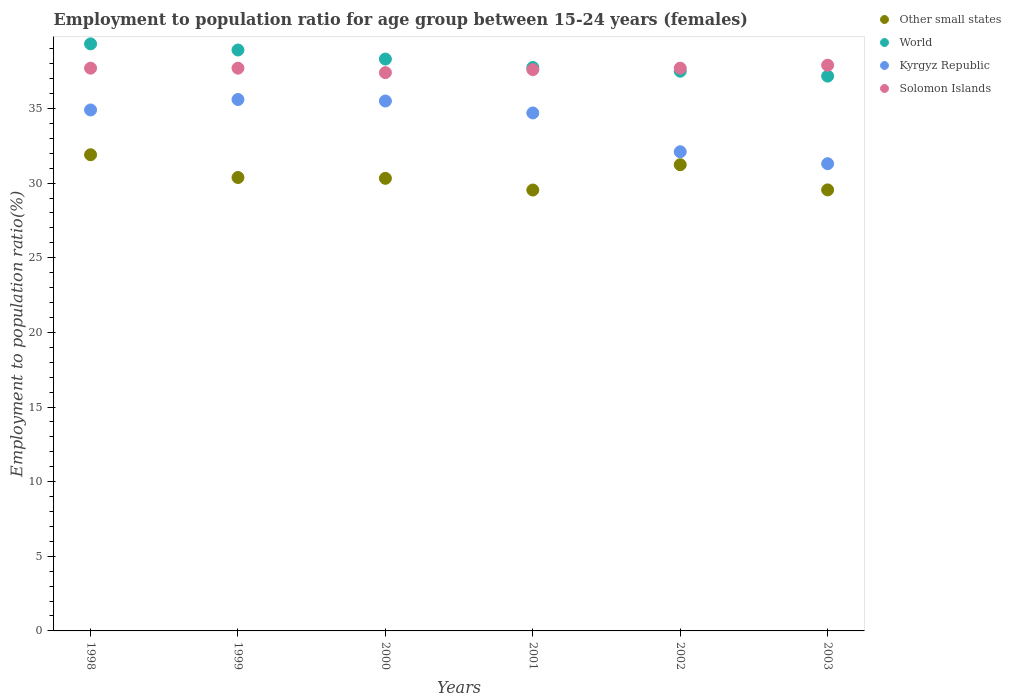How many different coloured dotlines are there?
Your answer should be compact. 4. What is the employment to population ratio in Other small states in 2003?
Keep it short and to the point. 29.55. Across all years, what is the maximum employment to population ratio in World?
Provide a succinct answer. 39.33. Across all years, what is the minimum employment to population ratio in Kyrgyz Republic?
Offer a terse response. 31.3. In which year was the employment to population ratio in Solomon Islands maximum?
Give a very brief answer. 2003. In which year was the employment to population ratio in Solomon Islands minimum?
Ensure brevity in your answer.  2000. What is the total employment to population ratio in World in the graph?
Your answer should be very brief. 228.97. What is the difference between the employment to population ratio in Kyrgyz Republic in 1999 and that in 2001?
Provide a succinct answer. 0.9. What is the difference between the employment to population ratio in Other small states in 2003 and the employment to population ratio in Kyrgyz Republic in 1999?
Offer a very short reply. -6.05. What is the average employment to population ratio in Kyrgyz Republic per year?
Your response must be concise. 34.02. In the year 1999, what is the difference between the employment to population ratio in World and employment to population ratio in Solomon Islands?
Offer a very short reply. 1.22. What is the ratio of the employment to population ratio in Other small states in 1999 to that in 2000?
Your response must be concise. 1. What is the difference between the highest and the second highest employment to population ratio in Other small states?
Keep it short and to the point. 0.67. Is it the case that in every year, the sum of the employment to population ratio in World and employment to population ratio in Solomon Islands  is greater than the sum of employment to population ratio in Other small states and employment to population ratio in Kyrgyz Republic?
Ensure brevity in your answer.  No. Is it the case that in every year, the sum of the employment to population ratio in Kyrgyz Republic and employment to population ratio in Other small states  is greater than the employment to population ratio in Solomon Islands?
Ensure brevity in your answer.  Yes. Does the employment to population ratio in Other small states monotonically increase over the years?
Your answer should be very brief. No. Is the employment to population ratio in Kyrgyz Republic strictly greater than the employment to population ratio in Solomon Islands over the years?
Offer a terse response. No. How many years are there in the graph?
Ensure brevity in your answer.  6. What is the difference between two consecutive major ticks on the Y-axis?
Your answer should be very brief. 5. Are the values on the major ticks of Y-axis written in scientific E-notation?
Provide a short and direct response. No. Does the graph contain grids?
Your answer should be very brief. No. How are the legend labels stacked?
Provide a short and direct response. Vertical. What is the title of the graph?
Keep it short and to the point. Employment to population ratio for age group between 15-24 years (females). What is the label or title of the Y-axis?
Keep it short and to the point. Employment to population ratio(%). What is the Employment to population ratio(%) of Other small states in 1998?
Provide a succinct answer. 31.9. What is the Employment to population ratio(%) in World in 1998?
Ensure brevity in your answer.  39.33. What is the Employment to population ratio(%) of Kyrgyz Republic in 1998?
Make the answer very short. 34.9. What is the Employment to population ratio(%) in Solomon Islands in 1998?
Ensure brevity in your answer.  37.7. What is the Employment to population ratio(%) of Other small states in 1999?
Ensure brevity in your answer.  30.38. What is the Employment to population ratio(%) of World in 1999?
Ensure brevity in your answer.  38.92. What is the Employment to population ratio(%) of Kyrgyz Republic in 1999?
Offer a terse response. 35.6. What is the Employment to population ratio(%) in Solomon Islands in 1999?
Offer a very short reply. 37.7. What is the Employment to population ratio(%) of Other small states in 2000?
Provide a short and direct response. 30.32. What is the Employment to population ratio(%) in World in 2000?
Ensure brevity in your answer.  38.31. What is the Employment to population ratio(%) of Kyrgyz Republic in 2000?
Ensure brevity in your answer.  35.5. What is the Employment to population ratio(%) of Solomon Islands in 2000?
Offer a terse response. 37.4. What is the Employment to population ratio(%) in Other small states in 2001?
Your answer should be very brief. 29.54. What is the Employment to population ratio(%) of World in 2001?
Make the answer very short. 37.75. What is the Employment to population ratio(%) of Kyrgyz Republic in 2001?
Make the answer very short. 34.7. What is the Employment to population ratio(%) of Solomon Islands in 2001?
Make the answer very short. 37.6. What is the Employment to population ratio(%) in Other small states in 2002?
Give a very brief answer. 31.23. What is the Employment to population ratio(%) in World in 2002?
Provide a short and direct response. 37.5. What is the Employment to population ratio(%) in Kyrgyz Republic in 2002?
Keep it short and to the point. 32.1. What is the Employment to population ratio(%) in Solomon Islands in 2002?
Make the answer very short. 37.7. What is the Employment to population ratio(%) of Other small states in 2003?
Provide a succinct answer. 29.55. What is the Employment to population ratio(%) in World in 2003?
Ensure brevity in your answer.  37.17. What is the Employment to population ratio(%) of Kyrgyz Republic in 2003?
Provide a short and direct response. 31.3. What is the Employment to population ratio(%) in Solomon Islands in 2003?
Provide a short and direct response. 37.9. Across all years, what is the maximum Employment to population ratio(%) of Other small states?
Your answer should be very brief. 31.9. Across all years, what is the maximum Employment to population ratio(%) of World?
Provide a succinct answer. 39.33. Across all years, what is the maximum Employment to population ratio(%) of Kyrgyz Republic?
Provide a short and direct response. 35.6. Across all years, what is the maximum Employment to population ratio(%) of Solomon Islands?
Ensure brevity in your answer.  37.9. Across all years, what is the minimum Employment to population ratio(%) in Other small states?
Give a very brief answer. 29.54. Across all years, what is the minimum Employment to population ratio(%) of World?
Provide a succinct answer. 37.17. Across all years, what is the minimum Employment to population ratio(%) of Kyrgyz Republic?
Keep it short and to the point. 31.3. Across all years, what is the minimum Employment to population ratio(%) in Solomon Islands?
Your response must be concise. 37.4. What is the total Employment to population ratio(%) in Other small states in the graph?
Your answer should be very brief. 182.91. What is the total Employment to population ratio(%) in World in the graph?
Offer a terse response. 228.97. What is the total Employment to population ratio(%) in Kyrgyz Republic in the graph?
Your response must be concise. 204.1. What is the total Employment to population ratio(%) in Solomon Islands in the graph?
Provide a succinct answer. 226. What is the difference between the Employment to population ratio(%) in Other small states in 1998 and that in 1999?
Provide a succinct answer. 1.52. What is the difference between the Employment to population ratio(%) of World in 1998 and that in 1999?
Provide a short and direct response. 0.41. What is the difference between the Employment to population ratio(%) in Kyrgyz Republic in 1998 and that in 1999?
Give a very brief answer. -0.7. What is the difference between the Employment to population ratio(%) in Solomon Islands in 1998 and that in 1999?
Provide a short and direct response. 0. What is the difference between the Employment to population ratio(%) of Other small states in 1998 and that in 2000?
Ensure brevity in your answer.  1.58. What is the difference between the Employment to population ratio(%) of World in 1998 and that in 2000?
Give a very brief answer. 1.02. What is the difference between the Employment to population ratio(%) of Other small states in 1998 and that in 2001?
Your answer should be very brief. 2.36. What is the difference between the Employment to population ratio(%) of World in 1998 and that in 2001?
Offer a terse response. 1.58. What is the difference between the Employment to population ratio(%) in Kyrgyz Republic in 1998 and that in 2001?
Offer a very short reply. 0.2. What is the difference between the Employment to population ratio(%) in Solomon Islands in 1998 and that in 2001?
Offer a terse response. 0.1. What is the difference between the Employment to population ratio(%) in Other small states in 1998 and that in 2002?
Provide a succinct answer. 0.67. What is the difference between the Employment to population ratio(%) in World in 1998 and that in 2002?
Offer a very short reply. 1.83. What is the difference between the Employment to population ratio(%) of Other small states in 1998 and that in 2003?
Offer a very short reply. 2.35. What is the difference between the Employment to population ratio(%) of World in 1998 and that in 2003?
Offer a very short reply. 2.16. What is the difference between the Employment to population ratio(%) of Kyrgyz Republic in 1998 and that in 2003?
Offer a very short reply. 3.6. What is the difference between the Employment to population ratio(%) in Other small states in 1999 and that in 2000?
Your answer should be very brief. 0.06. What is the difference between the Employment to population ratio(%) of World in 1999 and that in 2000?
Provide a succinct answer. 0.61. What is the difference between the Employment to population ratio(%) in Solomon Islands in 1999 and that in 2000?
Make the answer very short. 0.3. What is the difference between the Employment to population ratio(%) in Other small states in 1999 and that in 2001?
Your response must be concise. 0.84. What is the difference between the Employment to population ratio(%) of World in 1999 and that in 2001?
Keep it short and to the point. 1.17. What is the difference between the Employment to population ratio(%) of Solomon Islands in 1999 and that in 2001?
Provide a succinct answer. 0.1. What is the difference between the Employment to population ratio(%) of Other small states in 1999 and that in 2002?
Your response must be concise. -0.86. What is the difference between the Employment to population ratio(%) of World in 1999 and that in 2002?
Give a very brief answer. 1.42. What is the difference between the Employment to population ratio(%) of Other small states in 1999 and that in 2003?
Make the answer very short. 0.83. What is the difference between the Employment to population ratio(%) in World in 1999 and that in 2003?
Give a very brief answer. 1.75. What is the difference between the Employment to population ratio(%) in Solomon Islands in 1999 and that in 2003?
Offer a very short reply. -0.2. What is the difference between the Employment to population ratio(%) in Other small states in 2000 and that in 2001?
Give a very brief answer. 0.78. What is the difference between the Employment to population ratio(%) of World in 2000 and that in 2001?
Make the answer very short. 0.57. What is the difference between the Employment to population ratio(%) in Solomon Islands in 2000 and that in 2001?
Provide a short and direct response. -0.2. What is the difference between the Employment to population ratio(%) of Other small states in 2000 and that in 2002?
Give a very brief answer. -0.91. What is the difference between the Employment to population ratio(%) of World in 2000 and that in 2002?
Ensure brevity in your answer.  0.81. What is the difference between the Employment to population ratio(%) in Kyrgyz Republic in 2000 and that in 2002?
Provide a short and direct response. 3.4. What is the difference between the Employment to population ratio(%) of Solomon Islands in 2000 and that in 2002?
Offer a terse response. -0.3. What is the difference between the Employment to population ratio(%) in Other small states in 2000 and that in 2003?
Ensure brevity in your answer.  0.78. What is the difference between the Employment to population ratio(%) of World in 2000 and that in 2003?
Keep it short and to the point. 1.14. What is the difference between the Employment to population ratio(%) in Kyrgyz Republic in 2000 and that in 2003?
Make the answer very short. 4.2. What is the difference between the Employment to population ratio(%) of Solomon Islands in 2000 and that in 2003?
Your answer should be compact. -0.5. What is the difference between the Employment to population ratio(%) of Other small states in 2001 and that in 2002?
Your answer should be very brief. -1.69. What is the difference between the Employment to population ratio(%) of World in 2001 and that in 2002?
Your answer should be compact. 0.25. What is the difference between the Employment to population ratio(%) of Kyrgyz Republic in 2001 and that in 2002?
Your response must be concise. 2.6. What is the difference between the Employment to population ratio(%) of Other small states in 2001 and that in 2003?
Your answer should be very brief. -0.01. What is the difference between the Employment to population ratio(%) in World in 2001 and that in 2003?
Give a very brief answer. 0.58. What is the difference between the Employment to population ratio(%) of Other small states in 2002 and that in 2003?
Give a very brief answer. 1.69. What is the difference between the Employment to population ratio(%) in World in 2002 and that in 2003?
Provide a succinct answer. 0.33. What is the difference between the Employment to population ratio(%) of Other small states in 1998 and the Employment to population ratio(%) of World in 1999?
Offer a terse response. -7.02. What is the difference between the Employment to population ratio(%) in Other small states in 1998 and the Employment to population ratio(%) in Kyrgyz Republic in 1999?
Your response must be concise. -3.7. What is the difference between the Employment to population ratio(%) in Other small states in 1998 and the Employment to population ratio(%) in Solomon Islands in 1999?
Your answer should be compact. -5.8. What is the difference between the Employment to population ratio(%) of World in 1998 and the Employment to population ratio(%) of Kyrgyz Republic in 1999?
Offer a very short reply. 3.73. What is the difference between the Employment to population ratio(%) of World in 1998 and the Employment to population ratio(%) of Solomon Islands in 1999?
Provide a short and direct response. 1.63. What is the difference between the Employment to population ratio(%) of Other small states in 1998 and the Employment to population ratio(%) of World in 2000?
Give a very brief answer. -6.41. What is the difference between the Employment to population ratio(%) in Other small states in 1998 and the Employment to population ratio(%) in Kyrgyz Republic in 2000?
Provide a short and direct response. -3.6. What is the difference between the Employment to population ratio(%) in Other small states in 1998 and the Employment to population ratio(%) in Solomon Islands in 2000?
Provide a short and direct response. -5.5. What is the difference between the Employment to population ratio(%) in World in 1998 and the Employment to population ratio(%) in Kyrgyz Republic in 2000?
Offer a terse response. 3.83. What is the difference between the Employment to population ratio(%) of World in 1998 and the Employment to population ratio(%) of Solomon Islands in 2000?
Offer a very short reply. 1.93. What is the difference between the Employment to population ratio(%) in Other small states in 1998 and the Employment to population ratio(%) in World in 2001?
Provide a succinct answer. -5.85. What is the difference between the Employment to population ratio(%) of Other small states in 1998 and the Employment to population ratio(%) of Kyrgyz Republic in 2001?
Ensure brevity in your answer.  -2.8. What is the difference between the Employment to population ratio(%) in Other small states in 1998 and the Employment to population ratio(%) in Solomon Islands in 2001?
Give a very brief answer. -5.7. What is the difference between the Employment to population ratio(%) in World in 1998 and the Employment to population ratio(%) in Kyrgyz Republic in 2001?
Offer a terse response. 4.63. What is the difference between the Employment to population ratio(%) of World in 1998 and the Employment to population ratio(%) of Solomon Islands in 2001?
Ensure brevity in your answer.  1.73. What is the difference between the Employment to population ratio(%) in Kyrgyz Republic in 1998 and the Employment to population ratio(%) in Solomon Islands in 2001?
Ensure brevity in your answer.  -2.7. What is the difference between the Employment to population ratio(%) of Other small states in 1998 and the Employment to population ratio(%) of World in 2002?
Your answer should be very brief. -5.6. What is the difference between the Employment to population ratio(%) in Other small states in 1998 and the Employment to population ratio(%) in Kyrgyz Republic in 2002?
Your answer should be very brief. -0.2. What is the difference between the Employment to population ratio(%) of Other small states in 1998 and the Employment to population ratio(%) of Solomon Islands in 2002?
Provide a short and direct response. -5.8. What is the difference between the Employment to population ratio(%) in World in 1998 and the Employment to population ratio(%) in Kyrgyz Republic in 2002?
Your response must be concise. 7.23. What is the difference between the Employment to population ratio(%) in World in 1998 and the Employment to population ratio(%) in Solomon Islands in 2002?
Your answer should be very brief. 1.63. What is the difference between the Employment to population ratio(%) in Other small states in 1998 and the Employment to population ratio(%) in World in 2003?
Provide a succinct answer. -5.27. What is the difference between the Employment to population ratio(%) of Other small states in 1998 and the Employment to population ratio(%) of Kyrgyz Republic in 2003?
Offer a terse response. 0.6. What is the difference between the Employment to population ratio(%) of Other small states in 1998 and the Employment to population ratio(%) of Solomon Islands in 2003?
Offer a terse response. -6. What is the difference between the Employment to population ratio(%) in World in 1998 and the Employment to population ratio(%) in Kyrgyz Republic in 2003?
Offer a very short reply. 8.03. What is the difference between the Employment to population ratio(%) of World in 1998 and the Employment to population ratio(%) of Solomon Islands in 2003?
Offer a terse response. 1.43. What is the difference between the Employment to population ratio(%) of Other small states in 1999 and the Employment to population ratio(%) of World in 2000?
Make the answer very short. -7.93. What is the difference between the Employment to population ratio(%) of Other small states in 1999 and the Employment to population ratio(%) of Kyrgyz Republic in 2000?
Offer a very short reply. -5.12. What is the difference between the Employment to population ratio(%) of Other small states in 1999 and the Employment to population ratio(%) of Solomon Islands in 2000?
Ensure brevity in your answer.  -7.02. What is the difference between the Employment to population ratio(%) in World in 1999 and the Employment to population ratio(%) in Kyrgyz Republic in 2000?
Give a very brief answer. 3.42. What is the difference between the Employment to population ratio(%) of World in 1999 and the Employment to population ratio(%) of Solomon Islands in 2000?
Offer a terse response. 1.52. What is the difference between the Employment to population ratio(%) of Kyrgyz Republic in 1999 and the Employment to population ratio(%) of Solomon Islands in 2000?
Ensure brevity in your answer.  -1.8. What is the difference between the Employment to population ratio(%) of Other small states in 1999 and the Employment to population ratio(%) of World in 2001?
Keep it short and to the point. -7.37. What is the difference between the Employment to population ratio(%) of Other small states in 1999 and the Employment to population ratio(%) of Kyrgyz Republic in 2001?
Your answer should be compact. -4.32. What is the difference between the Employment to population ratio(%) in Other small states in 1999 and the Employment to population ratio(%) in Solomon Islands in 2001?
Offer a very short reply. -7.22. What is the difference between the Employment to population ratio(%) of World in 1999 and the Employment to population ratio(%) of Kyrgyz Republic in 2001?
Ensure brevity in your answer.  4.22. What is the difference between the Employment to population ratio(%) of World in 1999 and the Employment to population ratio(%) of Solomon Islands in 2001?
Your answer should be very brief. 1.32. What is the difference between the Employment to population ratio(%) of Kyrgyz Republic in 1999 and the Employment to population ratio(%) of Solomon Islands in 2001?
Ensure brevity in your answer.  -2. What is the difference between the Employment to population ratio(%) of Other small states in 1999 and the Employment to population ratio(%) of World in 2002?
Make the answer very short. -7.12. What is the difference between the Employment to population ratio(%) in Other small states in 1999 and the Employment to population ratio(%) in Kyrgyz Republic in 2002?
Make the answer very short. -1.72. What is the difference between the Employment to population ratio(%) of Other small states in 1999 and the Employment to population ratio(%) of Solomon Islands in 2002?
Make the answer very short. -7.32. What is the difference between the Employment to population ratio(%) of World in 1999 and the Employment to population ratio(%) of Kyrgyz Republic in 2002?
Ensure brevity in your answer.  6.82. What is the difference between the Employment to population ratio(%) of World in 1999 and the Employment to population ratio(%) of Solomon Islands in 2002?
Offer a terse response. 1.22. What is the difference between the Employment to population ratio(%) in Kyrgyz Republic in 1999 and the Employment to population ratio(%) in Solomon Islands in 2002?
Offer a terse response. -2.1. What is the difference between the Employment to population ratio(%) in Other small states in 1999 and the Employment to population ratio(%) in World in 2003?
Offer a terse response. -6.79. What is the difference between the Employment to population ratio(%) in Other small states in 1999 and the Employment to population ratio(%) in Kyrgyz Republic in 2003?
Provide a succinct answer. -0.92. What is the difference between the Employment to population ratio(%) in Other small states in 1999 and the Employment to population ratio(%) in Solomon Islands in 2003?
Make the answer very short. -7.52. What is the difference between the Employment to population ratio(%) in World in 1999 and the Employment to population ratio(%) in Kyrgyz Republic in 2003?
Your answer should be compact. 7.62. What is the difference between the Employment to population ratio(%) in World in 1999 and the Employment to population ratio(%) in Solomon Islands in 2003?
Ensure brevity in your answer.  1.02. What is the difference between the Employment to population ratio(%) in Kyrgyz Republic in 1999 and the Employment to population ratio(%) in Solomon Islands in 2003?
Your response must be concise. -2.3. What is the difference between the Employment to population ratio(%) of Other small states in 2000 and the Employment to population ratio(%) of World in 2001?
Your response must be concise. -7.43. What is the difference between the Employment to population ratio(%) in Other small states in 2000 and the Employment to population ratio(%) in Kyrgyz Republic in 2001?
Make the answer very short. -4.38. What is the difference between the Employment to population ratio(%) of Other small states in 2000 and the Employment to population ratio(%) of Solomon Islands in 2001?
Offer a terse response. -7.28. What is the difference between the Employment to population ratio(%) of World in 2000 and the Employment to population ratio(%) of Kyrgyz Republic in 2001?
Offer a very short reply. 3.61. What is the difference between the Employment to population ratio(%) in World in 2000 and the Employment to population ratio(%) in Solomon Islands in 2001?
Keep it short and to the point. 0.71. What is the difference between the Employment to population ratio(%) of Kyrgyz Republic in 2000 and the Employment to population ratio(%) of Solomon Islands in 2001?
Your answer should be compact. -2.1. What is the difference between the Employment to population ratio(%) of Other small states in 2000 and the Employment to population ratio(%) of World in 2002?
Your response must be concise. -7.18. What is the difference between the Employment to population ratio(%) of Other small states in 2000 and the Employment to population ratio(%) of Kyrgyz Republic in 2002?
Your answer should be very brief. -1.78. What is the difference between the Employment to population ratio(%) in Other small states in 2000 and the Employment to population ratio(%) in Solomon Islands in 2002?
Make the answer very short. -7.38. What is the difference between the Employment to population ratio(%) in World in 2000 and the Employment to population ratio(%) in Kyrgyz Republic in 2002?
Keep it short and to the point. 6.21. What is the difference between the Employment to population ratio(%) of World in 2000 and the Employment to population ratio(%) of Solomon Islands in 2002?
Provide a succinct answer. 0.61. What is the difference between the Employment to population ratio(%) of Other small states in 2000 and the Employment to population ratio(%) of World in 2003?
Ensure brevity in your answer.  -6.85. What is the difference between the Employment to population ratio(%) of Other small states in 2000 and the Employment to population ratio(%) of Kyrgyz Republic in 2003?
Ensure brevity in your answer.  -0.98. What is the difference between the Employment to population ratio(%) of Other small states in 2000 and the Employment to population ratio(%) of Solomon Islands in 2003?
Your answer should be very brief. -7.58. What is the difference between the Employment to population ratio(%) in World in 2000 and the Employment to population ratio(%) in Kyrgyz Republic in 2003?
Your answer should be very brief. 7.01. What is the difference between the Employment to population ratio(%) of World in 2000 and the Employment to population ratio(%) of Solomon Islands in 2003?
Provide a short and direct response. 0.41. What is the difference between the Employment to population ratio(%) in Other small states in 2001 and the Employment to population ratio(%) in World in 2002?
Offer a terse response. -7.96. What is the difference between the Employment to population ratio(%) in Other small states in 2001 and the Employment to population ratio(%) in Kyrgyz Republic in 2002?
Offer a very short reply. -2.56. What is the difference between the Employment to population ratio(%) of Other small states in 2001 and the Employment to population ratio(%) of Solomon Islands in 2002?
Provide a short and direct response. -8.16. What is the difference between the Employment to population ratio(%) of World in 2001 and the Employment to population ratio(%) of Kyrgyz Republic in 2002?
Give a very brief answer. 5.65. What is the difference between the Employment to population ratio(%) in World in 2001 and the Employment to population ratio(%) in Solomon Islands in 2002?
Your answer should be compact. 0.05. What is the difference between the Employment to population ratio(%) of Kyrgyz Republic in 2001 and the Employment to population ratio(%) of Solomon Islands in 2002?
Provide a short and direct response. -3. What is the difference between the Employment to population ratio(%) of Other small states in 2001 and the Employment to population ratio(%) of World in 2003?
Ensure brevity in your answer.  -7.63. What is the difference between the Employment to population ratio(%) in Other small states in 2001 and the Employment to population ratio(%) in Kyrgyz Republic in 2003?
Offer a terse response. -1.76. What is the difference between the Employment to population ratio(%) of Other small states in 2001 and the Employment to population ratio(%) of Solomon Islands in 2003?
Give a very brief answer. -8.36. What is the difference between the Employment to population ratio(%) in World in 2001 and the Employment to population ratio(%) in Kyrgyz Republic in 2003?
Ensure brevity in your answer.  6.45. What is the difference between the Employment to population ratio(%) in World in 2001 and the Employment to population ratio(%) in Solomon Islands in 2003?
Your answer should be very brief. -0.15. What is the difference between the Employment to population ratio(%) in Other small states in 2002 and the Employment to population ratio(%) in World in 2003?
Ensure brevity in your answer.  -5.94. What is the difference between the Employment to population ratio(%) in Other small states in 2002 and the Employment to population ratio(%) in Kyrgyz Republic in 2003?
Your response must be concise. -0.07. What is the difference between the Employment to population ratio(%) in Other small states in 2002 and the Employment to population ratio(%) in Solomon Islands in 2003?
Make the answer very short. -6.67. What is the difference between the Employment to population ratio(%) in World in 2002 and the Employment to population ratio(%) in Kyrgyz Republic in 2003?
Offer a terse response. 6.2. What is the difference between the Employment to population ratio(%) of World in 2002 and the Employment to population ratio(%) of Solomon Islands in 2003?
Provide a succinct answer. -0.4. What is the difference between the Employment to population ratio(%) in Kyrgyz Republic in 2002 and the Employment to population ratio(%) in Solomon Islands in 2003?
Keep it short and to the point. -5.8. What is the average Employment to population ratio(%) of Other small states per year?
Your answer should be very brief. 30.48. What is the average Employment to population ratio(%) of World per year?
Keep it short and to the point. 38.16. What is the average Employment to population ratio(%) of Kyrgyz Republic per year?
Make the answer very short. 34.02. What is the average Employment to population ratio(%) of Solomon Islands per year?
Your answer should be very brief. 37.67. In the year 1998, what is the difference between the Employment to population ratio(%) in Other small states and Employment to population ratio(%) in World?
Keep it short and to the point. -7.43. In the year 1998, what is the difference between the Employment to population ratio(%) of Other small states and Employment to population ratio(%) of Kyrgyz Republic?
Ensure brevity in your answer.  -3. In the year 1998, what is the difference between the Employment to population ratio(%) of Other small states and Employment to population ratio(%) of Solomon Islands?
Offer a terse response. -5.8. In the year 1998, what is the difference between the Employment to population ratio(%) in World and Employment to population ratio(%) in Kyrgyz Republic?
Provide a short and direct response. 4.43. In the year 1998, what is the difference between the Employment to population ratio(%) of World and Employment to population ratio(%) of Solomon Islands?
Make the answer very short. 1.63. In the year 1998, what is the difference between the Employment to population ratio(%) in Kyrgyz Republic and Employment to population ratio(%) in Solomon Islands?
Keep it short and to the point. -2.8. In the year 1999, what is the difference between the Employment to population ratio(%) of Other small states and Employment to population ratio(%) of World?
Ensure brevity in your answer.  -8.54. In the year 1999, what is the difference between the Employment to population ratio(%) of Other small states and Employment to population ratio(%) of Kyrgyz Republic?
Give a very brief answer. -5.22. In the year 1999, what is the difference between the Employment to population ratio(%) of Other small states and Employment to population ratio(%) of Solomon Islands?
Give a very brief answer. -7.32. In the year 1999, what is the difference between the Employment to population ratio(%) of World and Employment to population ratio(%) of Kyrgyz Republic?
Your answer should be very brief. 3.32. In the year 1999, what is the difference between the Employment to population ratio(%) of World and Employment to population ratio(%) of Solomon Islands?
Give a very brief answer. 1.22. In the year 2000, what is the difference between the Employment to population ratio(%) in Other small states and Employment to population ratio(%) in World?
Provide a succinct answer. -7.99. In the year 2000, what is the difference between the Employment to population ratio(%) in Other small states and Employment to population ratio(%) in Kyrgyz Republic?
Provide a succinct answer. -5.18. In the year 2000, what is the difference between the Employment to population ratio(%) in Other small states and Employment to population ratio(%) in Solomon Islands?
Provide a succinct answer. -7.08. In the year 2000, what is the difference between the Employment to population ratio(%) of World and Employment to population ratio(%) of Kyrgyz Republic?
Your answer should be compact. 2.81. In the year 2000, what is the difference between the Employment to population ratio(%) of World and Employment to population ratio(%) of Solomon Islands?
Make the answer very short. 0.91. In the year 2001, what is the difference between the Employment to population ratio(%) of Other small states and Employment to population ratio(%) of World?
Your response must be concise. -8.21. In the year 2001, what is the difference between the Employment to population ratio(%) of Other small states and Employment to population ratio(%) of Kyrgyz Republic?
Make the answer very short. -5.16. In the year 2001, what is the difference between the Employment to population ratio(%) in Other small states and Employment to population ratio(%) in Solomon Islands?
Keep it short and to the point. -8.06. In the year 2001, what is the difference between the Employment to population ratio(%) in World and Employment to population ratio(%) in Kyrgyz Republic?
Offer a very short reply. 3.05. In the year 2001, what is the difference between the Employment to population ratio(%) in World and Employment to population ratio(%) in Solomon Islands?
Offer a terse response. 0.15. In the year 2002, what is the difference between the Employment to population ratio(%) of Other small states and Employment to population ratio(%) of World?
Your response must be concise. -6.27. In the year 2002, what is the difference between the Employment to population ratio(%) in Other small states and Employment to population ratio(%) in Kyrgyz Republic?
Give a very brief answer. -0.87. In the year 2002, what is the difference between the Employment to population ratio(%) of Other small states and Employment to population ratio(%) of Solomon Islands?
Give a very brief answer. -6.47. In the year 2002, what is the difference between the Employment to population ratio(%) of World and Employment to population ratio(%) of Kyrgyz Republic?
Your response must be concise. 5.4. In the year 2002, what is the difference between the Employment to population ratio(%) in World and Employment to population ratio(%) in Solomon Islands?
Provide a short and direct response. -0.2. In the year 2002, what is the difference between the Employment to population ratio(%) in Kyrgyz Republic and Employment to population ratio(%) in Solomon Islands?
Provide a succinct answer. -5.6. In the year 2003, what is the difference between the Employment to population ratio(%) in Other small states and Employment to population ratio(%) in World?
Your answer should be compact. -7.62. In the year 2003, what is the difference between the Employment to population ratio(%) in Other small states and Employment to population ratio(%) in Kyrgyz Republic?
Keep it short and to the point. -1.75. In the year 2003, what is the difference between the Employment to population ratio(%) in Other small states and Employment to population ratio(%) in Solomon Islands?
Keep it short and to the point. -8.35. In the year 2003, what is the difference between the Employment to population ratio(%) of World and Employment to population ratio(%) of Kyrgyz Republic?
Offer a terse response. 5.87. In the year 2003, what is the difference between the Employment to population ratio(%) of World and Employment to population ratio(%) of Solomon Islands?
Give a very brief answer. -0.73. In the year 2003, what is the difference between the Employment to population ratio(%) of Kyrgyz Republic and Employment to population ratio(%) of Solomon Islands?
Your answer should be very brief. -6.6. What is the ratio of the Employment to population ratio(%) of Other small states in 1998 to that in 1999?
Offer a very short reply. 1.05. What is the ratio of the Employment to population ratio(%) of World in 1998 to that in 1999?
Make the answer very short. 1.01. What is the ratio of the Employment to population ratio(%) in Kyrgyz Republic in 1998 to that in 1999?
Make the answer very short. 0.98. What is the ratio of the Employment to population ratio(%) in Other small states in 1998 to that in 2000?
Your answer should be compact. 1.05. What is the ratio of the Employment to population ratio(%) in World in 1998 to that in 2000?
Provide a succinct answer. 1.03. What is the ratio of the Employment to population ratio(%) of Kyrgyz Republic in 1998 to that in 2000?
Provide a short and direct response. 0.98. What is the ratio of the Employment to population ratio(%) in Solomon Islands in 1998 to that in 2000?
Your response must be concise. 1.01. What is the ratio of the Employment to population ratio(%) in Other small states in 1998 to that in 2001?
Provide a succinct answer. 1.08. What is the ratio of the Employment to population ratio(%) of World in 1998 to that in 2001?
Ensure brevity in your answer.  1.04. What is the ratio of the Employment to population ratio(%) in Kyrgyz Republic in 1998 to that in 2001?
Offer a terse response. 1.01. What is the ratio of the Employment to population ratio(%) of Other small states in 1998 to that in 2002?
Offer a terse response. 1.02. What is the ratio of the Employment to population ratio(%) of World in 1998 to that in 2002?
Ensure brevity in your answer.  1.05. What is the ratio of the Employment to population ratio(%) in Kyrgyz Republic in 1998 to that in 2002?
Your response must be concise. 1.09. What is the ratio of the Employment to population ratio(%) of Other small states in 1998 to that in 2003?
Ensure brevity in your answer.  1.08. What is the ratio of the Employment to population ratio(%) in World in 1998 to that in 2003?
Your answer should be very brief. 1.06. What is the ratio of the Employment to population ratio(%) in Kyrgyz Republic in 1998 to that in 2003?
Provide a succinct answer. 1.11. What is the ratio of the Employment to population ratio(%) in Solomon Islands in 1998 to that in 2003?
Make the answer very short. 0.99. What is the ratio of the Employment to population ratio(%) of Other small states in 1999 to that in 2000?
Offer a very short reply. 1. What is the ratio of the Employment to population ratio(%) of World in 1999 to that in 2000?
Offer a terse response. 1.02. What is the ratio of the Employment to population ratio(%) in Other small states in 1999 to that in 2001?
Offer a terse response. 1.03. What is the ratio of the Employment to population ratio(%) of World in 1999 to that in 2001?
Your response must be concise. 1.03. What is the ratio of the Employment to population ratio(%) in Kyrgyz Republic in 1999 to that in 2001?
Keep it short and to the point. 1.03. What is the ratio of the Employment to population ratio(%) in Other small states in 1999 to that in 2002?
Your answer should be compact. 0.97. What is the ratio of the Employment to population ratio(%) in World in 1999 to that in 2002?
Provide a short and direct response. 1.04. What is the ratio of the Employment to population ratio(%) in Kyrgyz Republic in 1999 to that in 2002?
Your response must be concise. 1.11. What is the ratio of the Employment to population ratio(%) of Other small states in 1999 to that in 2003?
Your answer should be compact. 1.03. What is the ratio of the Employment to population ratio(%) in World in 1999 to that in 2003?
Offer a very short reply. 1.05. What is the ratio of the Employment to population ratio(%) of Kyrgyz Republic in 1999 to that in 2003?
Provide a succinct answer. 1.14. What is the ratio of the Employment to population ratio(%) in Other small states in 2000 to that in 2001?
Your answer should be compact. 1.03. What is the ratio of the Employment to population ratio(%) of World in 2000 to that in 2001?
Make the answer very short. 1.01. What is the ratio of the Employment to population ratio(%) of Kyrgyz Republic in 2000 to that in 2001?
Your response must be concise. 1.02. What is the ratio of the Employment to population ratio(%) in Solomon Islands in 2000 to that in 2001?
Make the answer very short. 0.99. What is the ratio of the Employment to population ratio(%) of Other small states in 2000 to that in 2002?
Offer a terse response. 0.97. What is the ratio of the Employment to population ratio(%) in World in 2000 to that in 2002?
Offer a very short reply. 1.02. What is the ratio of the Employment to population ratio(%) of Kyrgyz Republic in 2000 to that in 2002?
Make the answer very short. 1.11. What is the ratio of the Employment to population ratio(%) of Solomon Islands in 2000 to that in 2002?
Make the answer very short. 0.99. What is the ratio of the Employment to population ratio(%) in Other small states in 2000 to that in 2003?
Provide a succinct answer. 1.03. What is the ratio of the Employment to population ratio(%) of World in 2000 to that in 2003?
Offer a very short reply. 1.03. What is the ratio of the Employment to population ratio(%) in Kyrgyz Republic in 2000 to that in 2003?
Make the answer very short. 1.13. What is the ratio of the Employment to population ratio(%) in Solomon Islands in 2000 to that in 2003?
Make the answer very short. 0.99. What is the ratio of the Employment to population ratio(%) of Other small states in 2001 to that in 2002?
Give a very brief answer. 0.95. What is the ratio of the Employment to population ratio(%) of World in 2001 to that in 2002?
Give a very brief answer. 1.01. What is the ratio of the Employment to population ratio(%) of Kyrgyz Republic in 2001 to that in 2002?
Provide a succinct answer. 1.08. What is the ratio of the Employment to population ratio(%) in Other small states in 2001 to that in 2003?
Offer a terse response. 1. What is the ratio of the Employment to population ratio(%) of World in 2001 to that in 2003?
Provide a succinct answer. 1.02. What is the ratio of the Employment to population ratio(%) of Kyrgyz Republic in 2001 to that in 2003?
Your answer should be very brief. 1.11. What is the ratio of the Employment to population ratio(%) of Other small states in 2002 to that in 2003?
Offer a terse response. 1.06. What is the ratio of the Employment to population ratio(%) in World in 2002 to that in 2003?
Your answer should be compact. 1.01. What is the ratio of the Employment to population ratio(%) in Kyrgyz Republic in 2002 to that in 2003?
Offer a very short reply. 1.03. What is the difference between the highest and the second highest Employment to population ratio(%) of Other small states?
Keep it short and to the point. 0.67. What is the difference between the highest and the second highest Employment to population ratio(%) in World?
Your response must be concise. 0.41. What is the difference between the highest and the second highest Employment to population ratio(%) in Kyrgyz Republic?
Offer a terse response. 0.1. What is the difference between the highest and the second highest Employment to population ratio(%) of Solomon Islands?
Make the answer very short. 0.2. What is the difference between the highest and the lowest Employment to population ratio(%) in Other small states?
Your answer should be very brief. 2.36. What is the difference between the highest and the lowest Employment to population ratio(%) of World?
Ensure brevity in your answer.  2.16. 